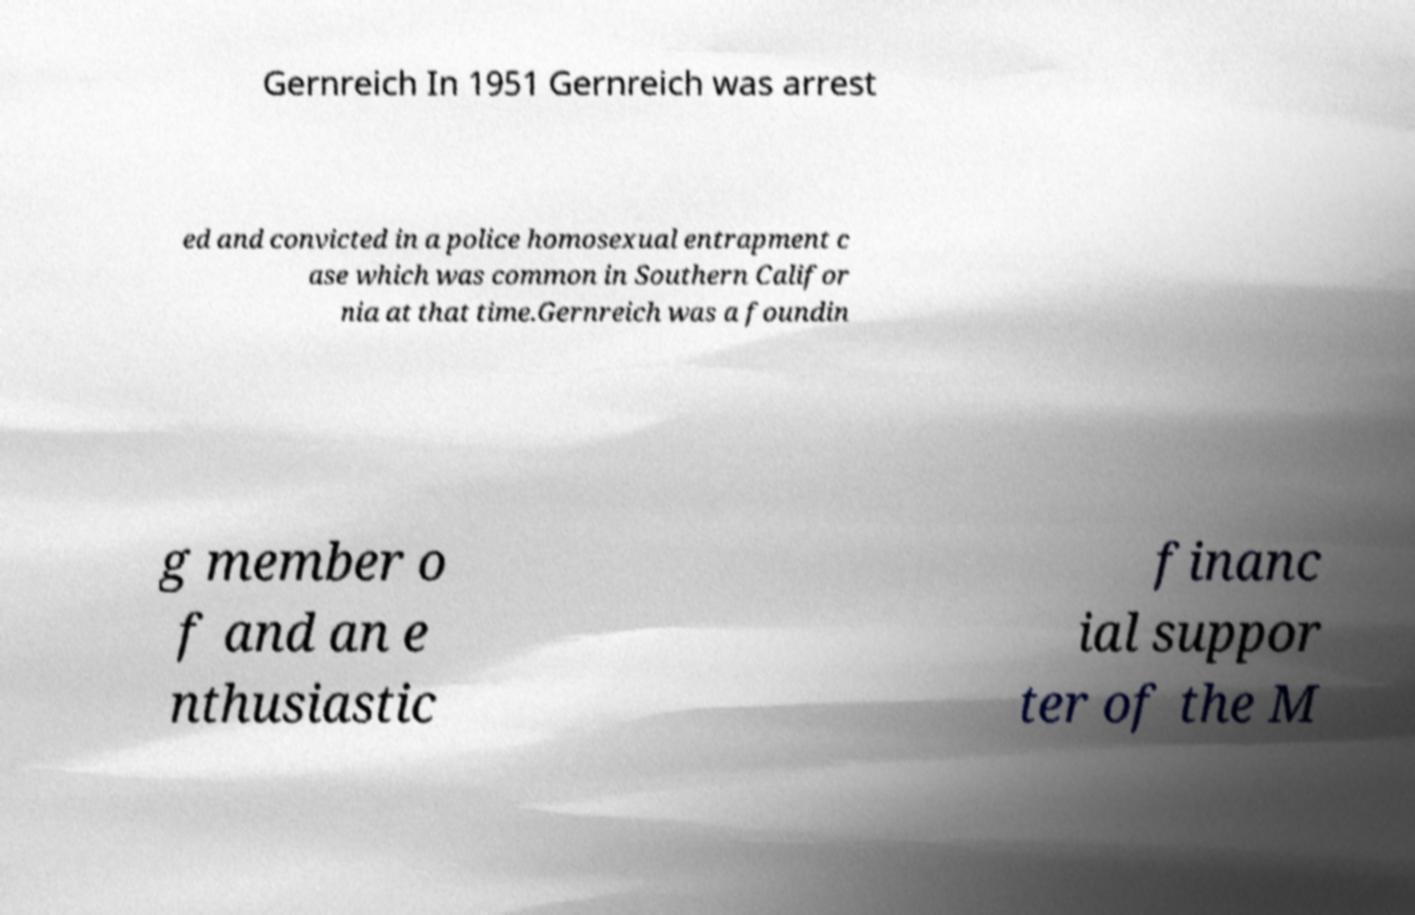Please identify and transcribe the text found in this image. Gernreich In 1951 Gernreich was arrest ed and convicted in a police homosexual entrapment c ase which was common in Southern Califor nia at that time.Gernreich was a foundin g member o f and an e nthusiastic financ ial suppor ter of the M 